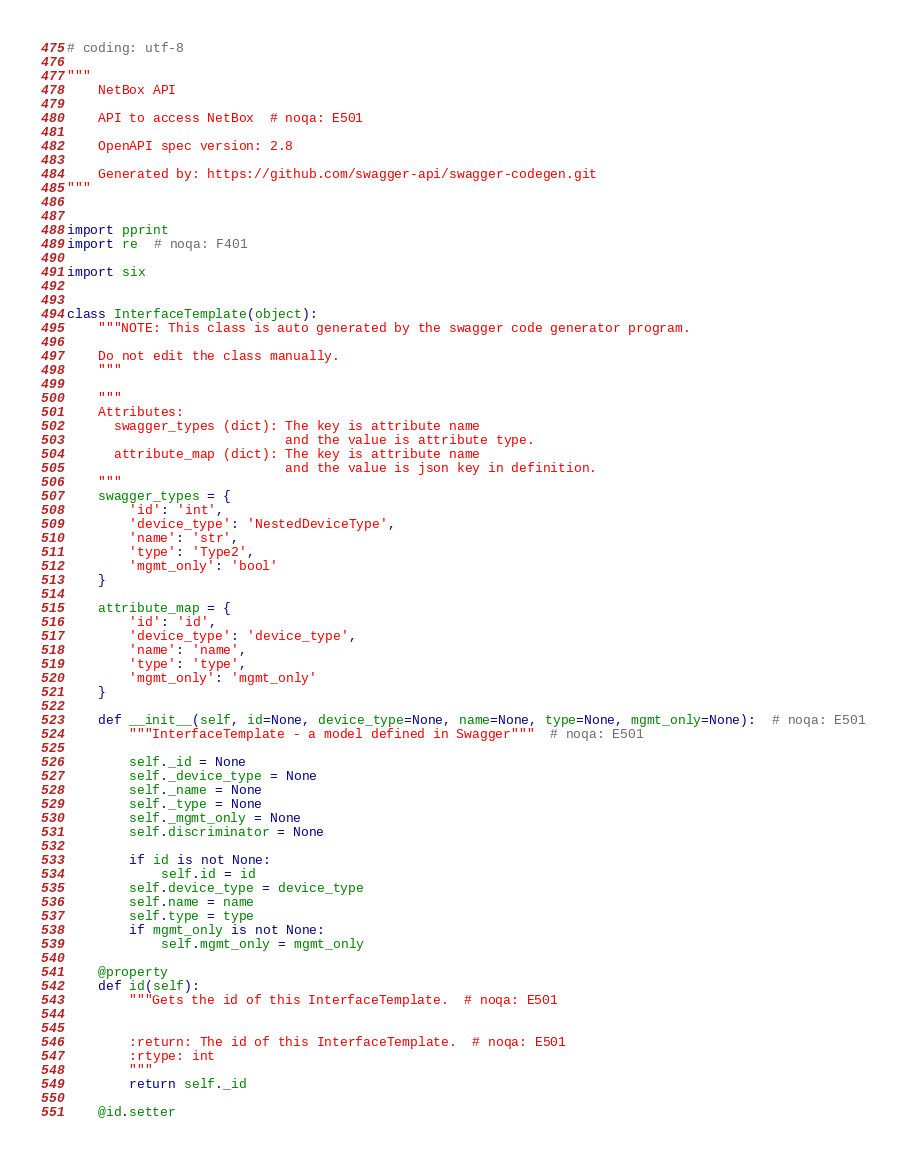Convert code to text. <code><loc_0><loc_0><loc_500><loc_500><_Python_># coding: utf-8

"""
    NetBox API

    API to access NetBox  # noqa: E501

    OpenAPI spec version: 2.8
    
    Generated by: https://github.com/swagger-api/swagger-codegen.git
"""


import pprint
import re  # noqa: F401

import six


class InterfaceTemplate(object):
    """NOTE: This class is auto generated by the swagger code generator program.

    Do not edit the class manually.
    """

    """
    Attributes:
      swagger_types (dict): The key is attribute name
                            and the value is attribute type.
      attribute_map (dict): The key is attribute name
                            and the value is json key in definition.
    """
    swagger_types = {
        'id': 'int',
        'device_type': 'NestedDeviceType',
        'name': 'str',
        'type': 'Type2',
        'mgmt_only': 'bool'
    }

    attribute_map = {
        'id': 'id',
        'device_type': 'device_type',
        'name': 'name',
        'type': 'type',
        'mgmt_only': 'mgmt_only'
    }

    def __init__(self, id=None, device_type=None, name=None, type=None, mgmt_only=None):  # noqa: E501
        """InterfaceTemplate - a model defined in Swagger"""  # noqa: E501

        self._id = None
        self._device_type = None
        self._name = None
        self._type = None
        self._mgmt_only = None
        self.discriminator = None

        if id is not None:
            self.id = id
        self.device_type = device_type
        self.name = name
        self.type = type
        if mgmt_only is not None:
            self.mgmt_only = mgmt_only

    @property
    def id(self):
        """Gets the id of this InterfaceTemplate.  # noqa: E501


        :return: The id of this InterfaceTemplate.  # noqa: E501
        :rtype: int
        """
        return self._id

    @id.setter</code> 